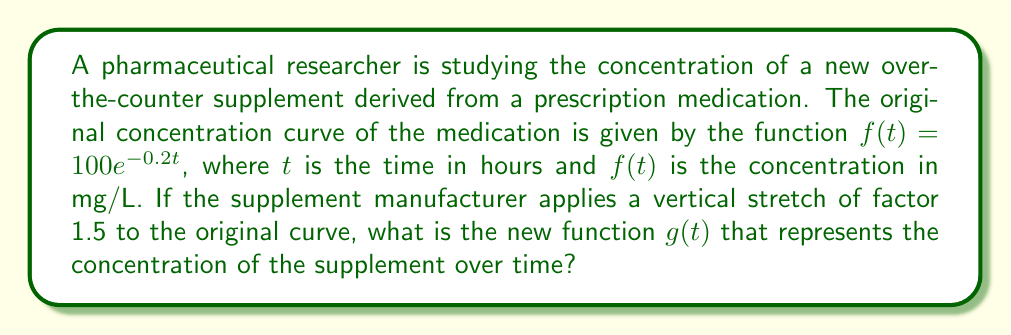Can you solve this math problem? To solve this problem, we need to understand the effect of vertical stretching on a function:

1) A vertical stretch by a factor of $k$ transforms a function $f(t)$ into $g(t) = kf(t)$.

2) In this case, the stretch factor is 1.5, so $k = 1.5$.

3) The original function is $f(t) = 100e^{-0.2t}$.

4) Applying the vertical stretch, we get:

   $g(t) = 1.5f(t)$
   $g(t) = 1.5(100e^{-0.2t})$

5) Simplifying:
   $g(t) = 150e^{-0.2t}$

This new function $g(t)$ represents the concentration curve of the supplement, which has been vertically stretched by a factor of 1.5 compared to the original medication.
Answer: $g(t) = 150e^{-0.2t}$ 